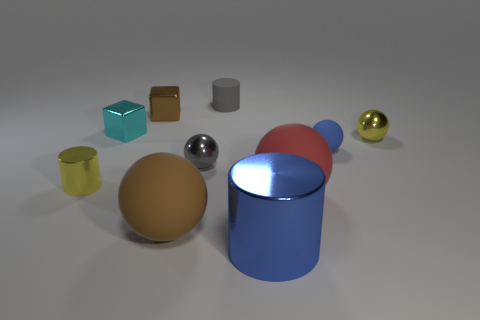Subtract all red matte spheres. How many spheres are left? 4 Subtract all gray spheres. How many spheres are left? 4 Subtract all yellow cylinders. Subtract all gray balls. How many cylinders are left? 2 Subtract all cylinders. How many objects are left? 7 Subtract all small gray cylinders. Subtract all tiny brown shiny things. How many objects are left? 8 Add 3 brown cubes. How many brown cubes are left? 4 Add 5 yellow metal things. How many yellow metal things exist? 7 Subtract 0 red cubes. How many objects are left? 10 